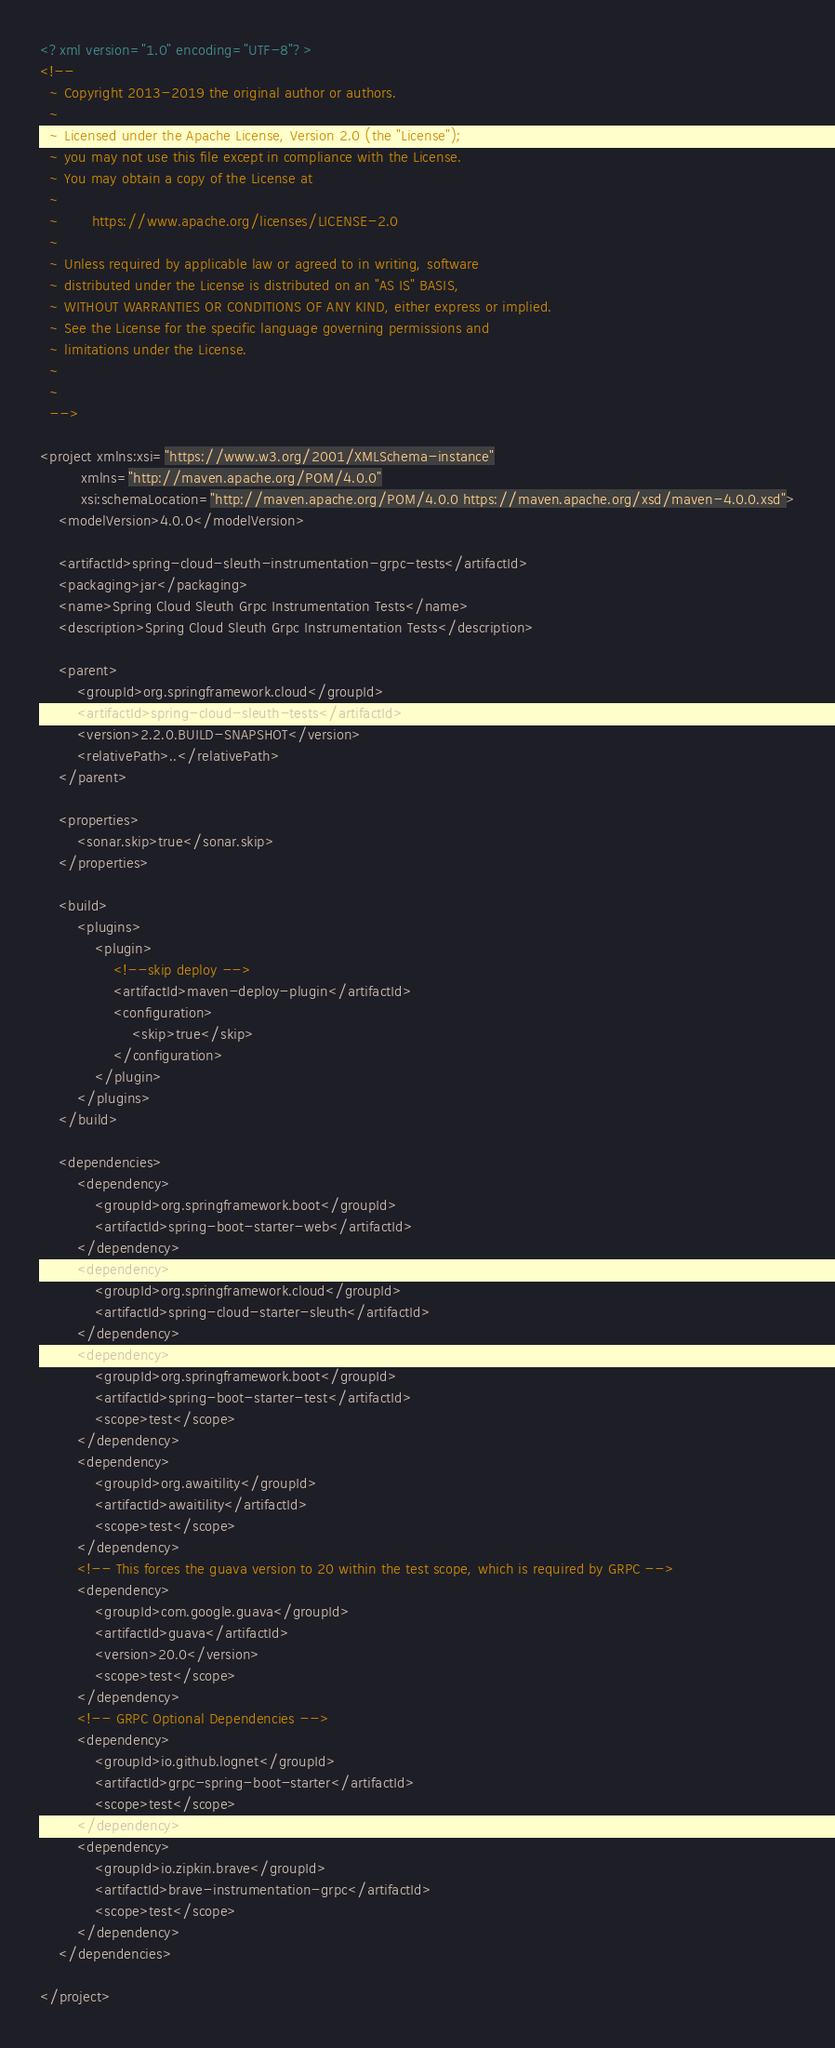Convert code to text. <code><loc_0><loc_0><loc_500><loc_500><_XML_><?xml version="1.0" encoding="UTF-8"?>
<!--
  ~ Copyright 2013-2019 the original author or authors.
  ~
  ~ Licensed under the Apache License, Version 2.0 (the "License");
  ~ you may not use this file except in compliance with the License.
  ~ You may obtain a copy of the License at
  ~
  ~       https://www.apache.org/licenses/LICENSE-2.0
  ~
  ~ Unless required by applicable law or agreed to in writing, software
  ~ distributed under the License is distributed on an "AS IS" BASIS,
  ~ WITHOUT WARRANTIES OR CONDITIONS OF ANY KIND, either express or implied.
  ~ See the License for the specific language governing permissions and
  ~ limitations under the License.
  ~
  ~
  -->

<project xmlns:xsi="https://www.w3.org/2001/XMLSchema-instance"
		 xmlns="http://maven.apache.org/POM/4.0.0"
		 xsi:schemaLocation="http://maven.apache.org/POM/4.0.0 https://maven.apache.org/xsd/maven-4.0.0.xsd">
	<modelVersion>4.0.0</modelVersion>

	<artifactId>spring-cloud-sleuth-instrumentation-grpc-tests</artifactId>
	<packaging>jar</packaging>
	<name>Spring Cloud Sleuth Grpc Instrumentation Tests</name>
	<description>Spring Cloud Sleuth Grpc Instrumentation Tests</description>

	<parent>
		<groupId>org.springframework.cloud</groupId>
		<artifactId>spring-cloud-sleuth-tests</artifactId>
		<version>2.2.0.BUILD-SNAPSHOT</version>
		<relativePath>..</relativePath>
	</parent>

	<properties>
		<sonar.skip>true</sonar.skip>
	</properties>

	<build>
		<plugins>
			<plugin>
				<!--skip deploy -->
				<artifactId>maven-deploy-plugin</artifactId>
				<configuration>
					<skip>true</skip>
				</configuration>
			</plugin>
		</plugins>
	</build>

	<dependencies>
		<dependency>
			<groupId>org.springframework.boot</groupId>
			<artifactId>spring-boot-starter-web</artifactId>
		</dependency>
		<dependency>
			<groupId>org.springframework.cloud</groupId>
			<artifactId>spring-cloud-starter-sleuth</artifactId>
		</dependency>
		<dependency>
			<groupId>org.springframework.boot</groupId>
			<artifactId>spring-boot-starter-test</artifactId>
			<scope>test</scope>
		</dependency>
		<dependency>
			<groupId>org.awaitility</groupId>
			<artifactId>awaitility</artifactId>
			<scope>test</scope>
		</dependency>
		<!-- This forces the guava version to 20 within the test scope, which is required by GRPC -->
		<dependency>
			<groupId>com.google.guava</groupId>
			<artifactId>guava</artifactId>
			<version>20.0</version>
			<scope>test</scope>
		</dependency>
		<!-- GRPC Optional Dependencies -->
		<dependency>
			<groupId>io.github.lognet</groupId>
			<artifactId>grpc-spring-boot-starter</artifactId>
			<scope>test</scope>
		</dependency>
		<dependency>
			<groupId>io.zipkin.brave</groupId>
			<artifactId>brave-instrumentation-grpc</artifactId>
			<scope>test</scope>
		</dependency>
	</dependencies>

</project>
</code> 